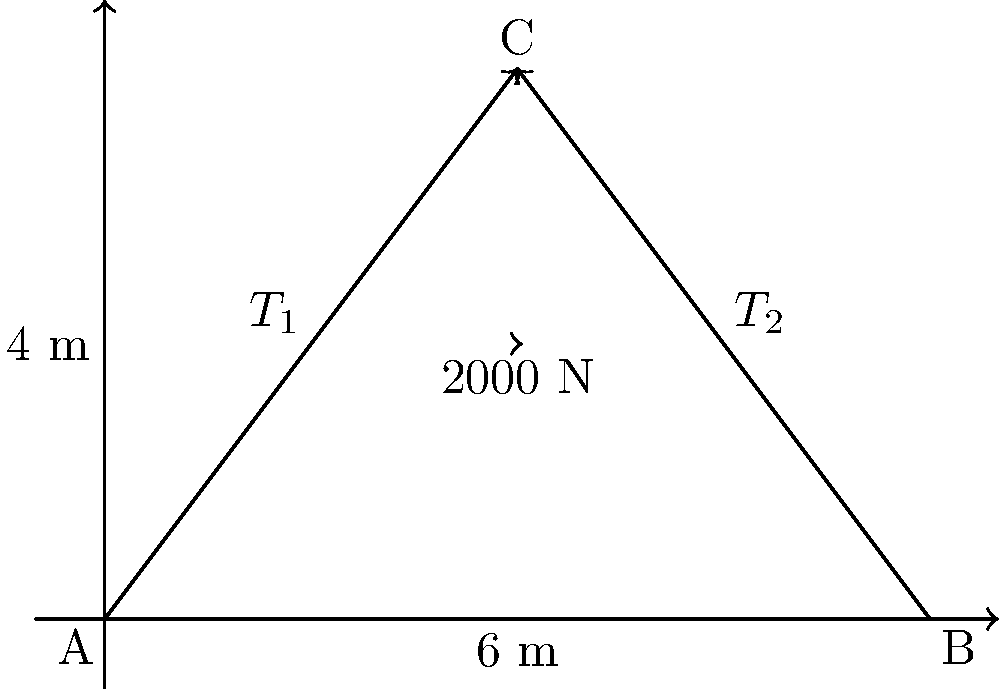A cable support system is set up at a construction site as shown in the diagram. Two cables, $T_1$ and $T_2$, are attached to points A and B respectively, meeting at point C where a load of 2000 N is suspended. If the horizontal distance between A and B is 6 m, and the vertical distance from the ground to point C is 4 m, calculate the tension in cable $T_1$. To solve this problem, we'll use vector decomposition and equilibrium equations. Let's follow these steps:

1) First, we need to find the angles of the cables:
   For $T_1$: $\tan \theta_1 = \frac{4}{3} = 1.333$
   $\theta_1 = \arctan(1.333) = 53.13°$

2) Now, we can set up the equilibrium equations:
   Vertical components: $T_1 \sin(53.13°) + T_2 \sin(53.13°) = 2000$ N
   Horizontal components: $T_1 \cos(53.13°) = T_2 \cos(53.13°)$

3) From the horizontal equation, we can conclude that $T_1 = T_2$

4) Substituting this into the vertical equation:
   $2T_1 \sin(53.13°) = 2000$ N

5) Solving for $T_1$:
   $T_1 = \frac{2000}{2\sin(53.13°)} = \frac{2000}{2(0.8) } = 1250$ N

Therefore, the tension in cable $T_1$ is 1250 N.
Answer: 1250 N 